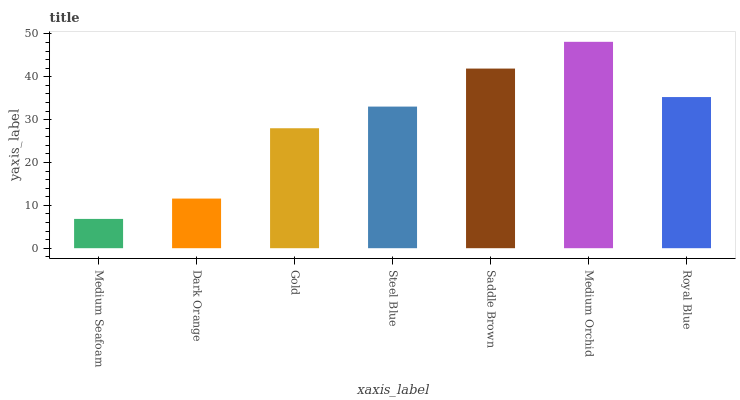Is Dark Orange the minimum?
Answer yes or no. No. Is Dark Orange the maximum?
Answer yes or no. No. Is Dark Orange greater than Medium Seafoam?
Answer yes or no. Yes. Is Medium Seafoam less than Dark Orange?
Answer yes or no. Yes. Is Medium Seafoam greater than Dark Orange?
Answer yes or no. No. Is Dark Orange less than Medium Seafoam?
Answer yes or no. No. Is Steel Blue the high median?
Answer yes or no. Yes. Is Steel Blue the low median?
Answer yes or no. Yes. Is Gold the high median?
Answer yes or no. No. Is Saddle Brown the low median?
Answer yes or no. No. 